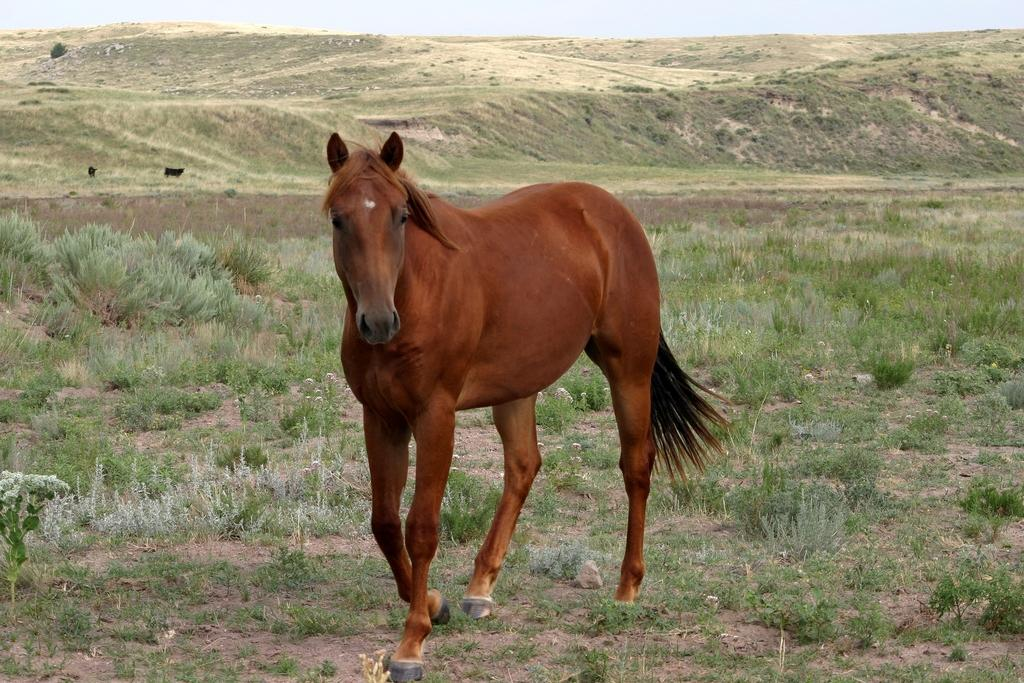What type of animal is in the image? There is an animal in the image, but its specific type is not mentioned in the facts. What color is the animal in the image? The animal is brown in color. What can be seen in the background of the image? There are plants and the sky visible in the background of the image. What color are the plants in the image? The plants are green in color. What color is the sky in the image? The sky is white in color. Is the animal wearing a collar in the image? There is no mention of a collar in the image, so it cannot be determined whether the animal is wearing one or not. Can you see any worms in the image? There is no mention of worms in the image, so it cannot be determined whether any are present or not. 